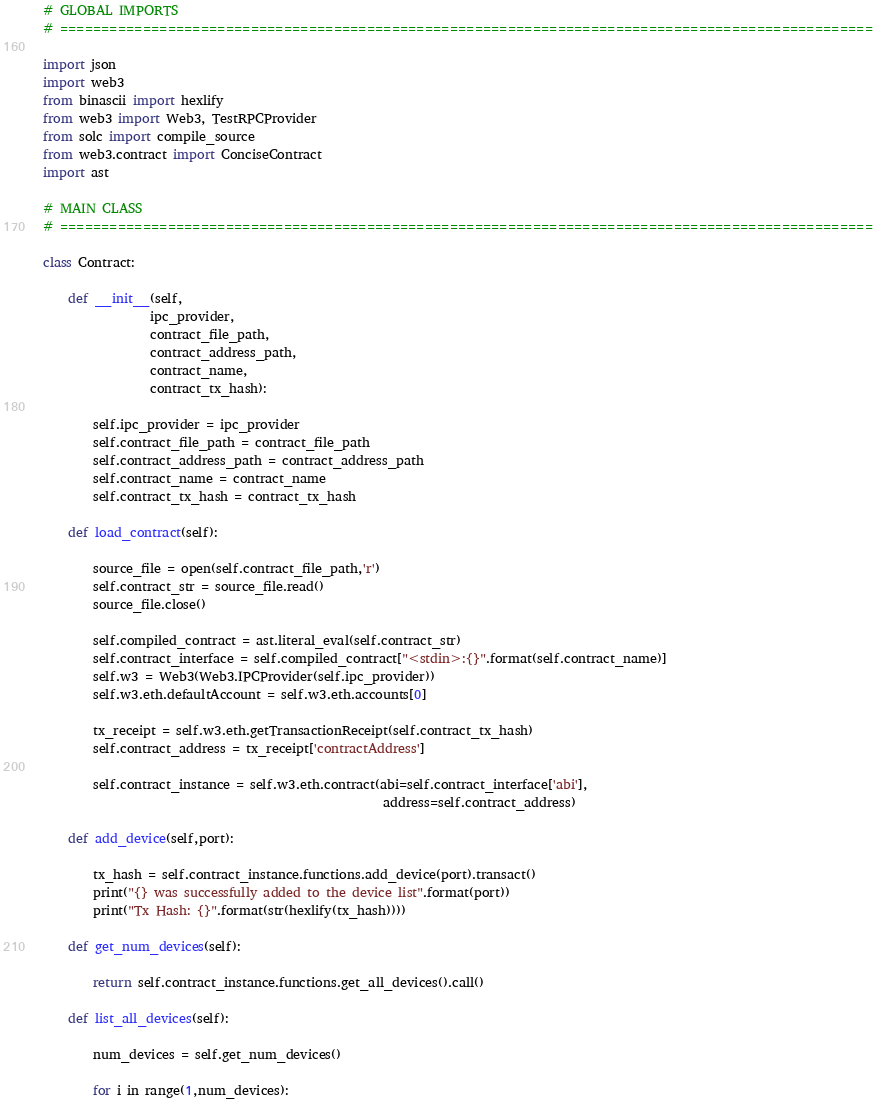Convert code to text. <code><loc_0><loc_0><loc_500><loc_500><_Python_># GLOBAL IMPORTS
# ==================================================================================================

import json
import web3
from binascii import hexlify
from web3 import Web3, TestRPCProvider
from solc import compile_source
from web3.contract import ConciseContract
import ast

# MAIN CLASS
# ==================================================================================================

class Contract:

    def __init__(self,
                 ipc_provider,
                 contract_file_path,
                 contract_address_path,
                 contract_name,
                 contract_tx_hash):
                 
        self.ipc_provider = ipc_provider
        self.contract_file_path = contract_file_path
        self.contract_address_path = contract_address_path
        self.contract_name = contract_name
        self.contract_tx_hash = contract_tx_hash

    def load_contract(self):

        source_file = open(self.contract_file_path,'r')
        self.contract_str = source_file.read()
        source_file.close()

        self.compiled_contract = ast.literal_eval(self.contract_str)
        self.contract_interface = self.compiled_contract["<stdin>:{}".format(self.contract_name)]
        self.w3 = Web3(Web3.IPCProvider(self.ipc_provider))
        self.w3.eth.defaultAccount = self.w3.eth.accounts[0]

        tx_receipt = self.w3.eth.getTransactionReceipt(self.contract_tx_hash)
        self.contract_address = tx_receipt['contractAddress']

        self.contract_instance = self.w3.eth.contract(abi=self.contract_interface['abi'], 
                                                      address=self.contract_address)
    
    def add_device(self,port):

        tx_hash = self.contract_instance.functions.add_device(port).transact()
        print("{} was successfully added to the device list".format(port))
        print("Tx Hash: {}".format(str(hexlify(tx_hash))))

    def get_num_devices(self):

        return self.contract_instance.functions.get_all_devices().call()

    def list_all_devices(self):

        num_devices = self.get_num_devices()

        for i in range(1,num_devices):</code> 